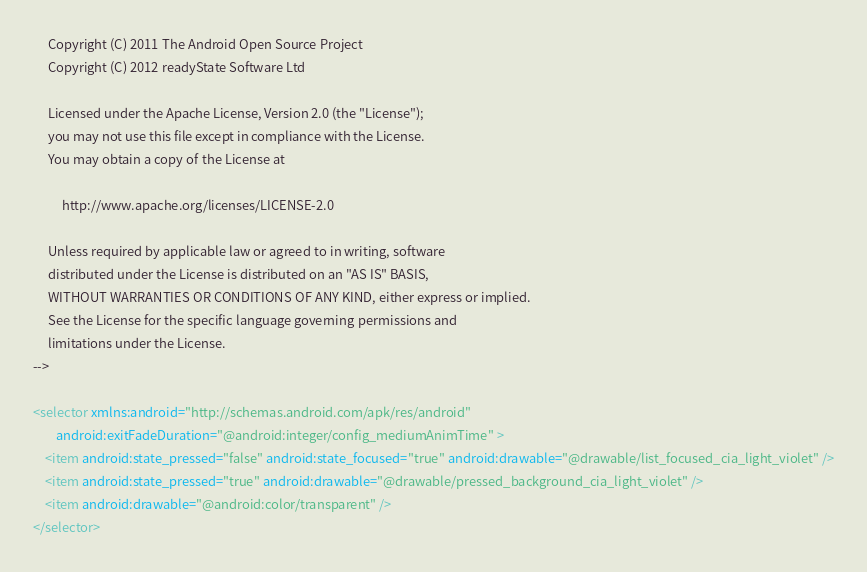<code> <loc_0><loc_0><loc_500><loc_500><_XML_>
     Copyright (C) 2011 The Android Open Source Project
     Copyright (C) 2012 readyState Software Ltd

     Licensed under the Apache License, Version 2.0 (the "License");
     you may not use this file except in compliance with the License.
     You may obtain a copy of the License at
  
          http://www.apache.org/licenses/LICENSE-2.0
  
     Unless required by applicable law or agreed to in writing, software
     distributed under the License is distributed on an "AS IS" BASIS,
     WITHOUT WARRANTIES OR CONDITIONS OF ANY KIND, either express or implied.
     See the License for the specific language governing permissions and
     limitations under the License.
-->

<selector xmlns:android="http://schemas.android.com/apk/res/android"
        android:exitFadeDuration="@android:integer/config_mediumAnimTime" >
    <item android:state_pressed="false" android:state_focused="true" android:drawable="@drawable/list_focused_cia_light_violet" />
    <item android:state_pressed="true" android:drawable="@drawable/pressed_background_cia_light_violet" />
    <item android:drawable="@android:color/transparent" />
</selector></code> 